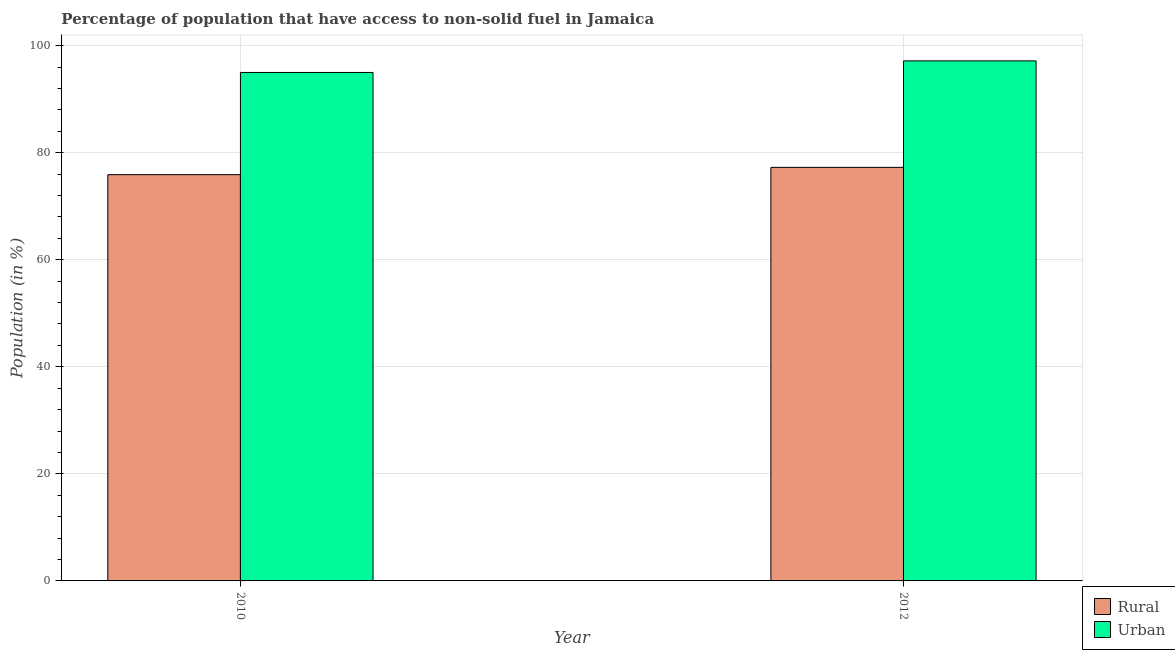How many different coloured bars are there?
Provide a succinct answer. 2. Are the number of bars per tick equal to the number of legend labels?
Keep it short and to the point. Yes. Are the number of bars on each tick of the X-axis equal?
Provide a succinct answer. Yes. How many bars are there on the 2nd tick from the left?
Give a very brief answer. 2. What is the label of the 2nd group of bars from the left?
Provide a succinct answer. 2012. What is the urban population in 2012?
Ensure brevity in your answer.  97.15. Across all years, what is the maximum urban population?
Offer a very short reply. 97.15. Across all years, what is the minimum urban population?
Your answer should be very brief. 94.98. What is the total urban population in the graph?
Provide a short and direct response. 192.13. What is the difference between the urban population in 2010 and that in 2012?
Make the answer very short. -2.16. What is the difference between the rural population in 2012 and the urban population in 2010?
Offer a terse response. 1.36. What is the average urban population per year?
Provide a short and direct response. 96.06. In the year 2010, what is the difference between the rural population and urban population?
Provide a short and direct response. 0. What is the ratio of the urban population in 2010 to that in 2012?
Provide a short and direct response. 0.98. Is the rural population in 2010 less than that in 2012?
Your answer should be compact. Yes. In how many years, is the urban population greater than the average urban population taken over all years?
Provide a succinct answer. 1. What does the 1st bar from the left in 2012 represents?
Ensure brevity in your answer.  Rural. What does the 2nd bar from the right in 2010 represents?
Provide a short and direct response. Rural. How many bars are there?
Your answer should be compact. 4. Are all the bars in the graph horizontal?
Ensure brevity in your answer.  No. How many years are there in the graph?
Provide a short and direct response. 2. What is the title of the graph?
Ensure brevity in your answer.  Percentage of population that have access to non-solid fuel in Jamaica. What is the Population (in %) of Rural in 2010?
Provide a succinct answer. 75.89. What is the Population (in %) in Urban in 2010?
Give a very brief answer. 94.98. What is the Population (in %) in Rural in 2012?
Keep it short and to the point. 77.25. What is the Population (in %) of Urban in 2012?
Give a very brief answer. 97.15. Across all years, what is the maximum Population (in %) of Rural?
Your answer should be compact. 77.25. Across all years, what is the maximum Population (in %) in Urban?
Give a very brief answer. 97.15. Across all years, what is the minimum Population (in %) in Rural?
Ensure brevity in your answer.  75.89. Across all years, what is the minimum Population (in %) of Urban?
Offer a terse response. 94.98. What is the total Population (in %) of Rural in the graph?
Give a very brief answer. 153.14. What is the total Population (in %) of Urban in the graph?
Provide a succinct answer. 192.13. What is the difference between the Population (in %) in Rural in 2010 and that in 2012?
Offer a very short reply. -1.36. What is the difference between the Population (in %) of Urban in 2010 and that in 2012?
Provide a short and direct response. -2.16. What is the difference between the Population (in %) of Rural in 2010 and the Population (in %) of Urban in 2012?
Your response must be concise. -21.26. What is the average Population (in %) in Rural per year?
Offer a very short reply. 76.57. What is the average Population (in %) of Urban per year?
Give a very brief answer. 96.06. In the year 2010, what is the difference between the Population (in %) of Rural and Population (in %) of Urban?
Your answer should be very brief. -19.09. In the year 2012, what is the difference between the Population (in %) of Rural and Population (in %) of Urban?
Your answer should be very brief. -19.89. What is the ratio of the Population (in %) of Rural in 2010 to that in 2012?
Ensure brevity in your answer.  0.98. What is the ratio of the Population (in %) in Urban in 2010 to that in 2012?
Your response must be concise. 0.98. What is the difference between the highest and the second highest Population (in %) of Rural?
Your answer should be very brief. 1.36. What is the difference between the highest and the second highest Population (in %) in Urban?
Provide a succinct answer. 2.16. What is the difference between the highest and the lowest Population (in %) in Rural?
Give a very brief answer. 1.36. What is the difference between the highest and the lowest Population (in %) of Urban?
Make the answer very short. 2.16. 